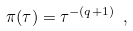<formula> <loc_0><loc_0><loc_500><loc_500>\pi ( \tau ) = \tau ^ { - ( q + 1 ) } \ ,</formula> 